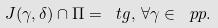<formula> <loc_0><loc_0><loc_500><loc_500>J ( \gamma , \delta ) \cap \Pi = \ t g , \, \forall \gamma \in \ p p .</formula> 